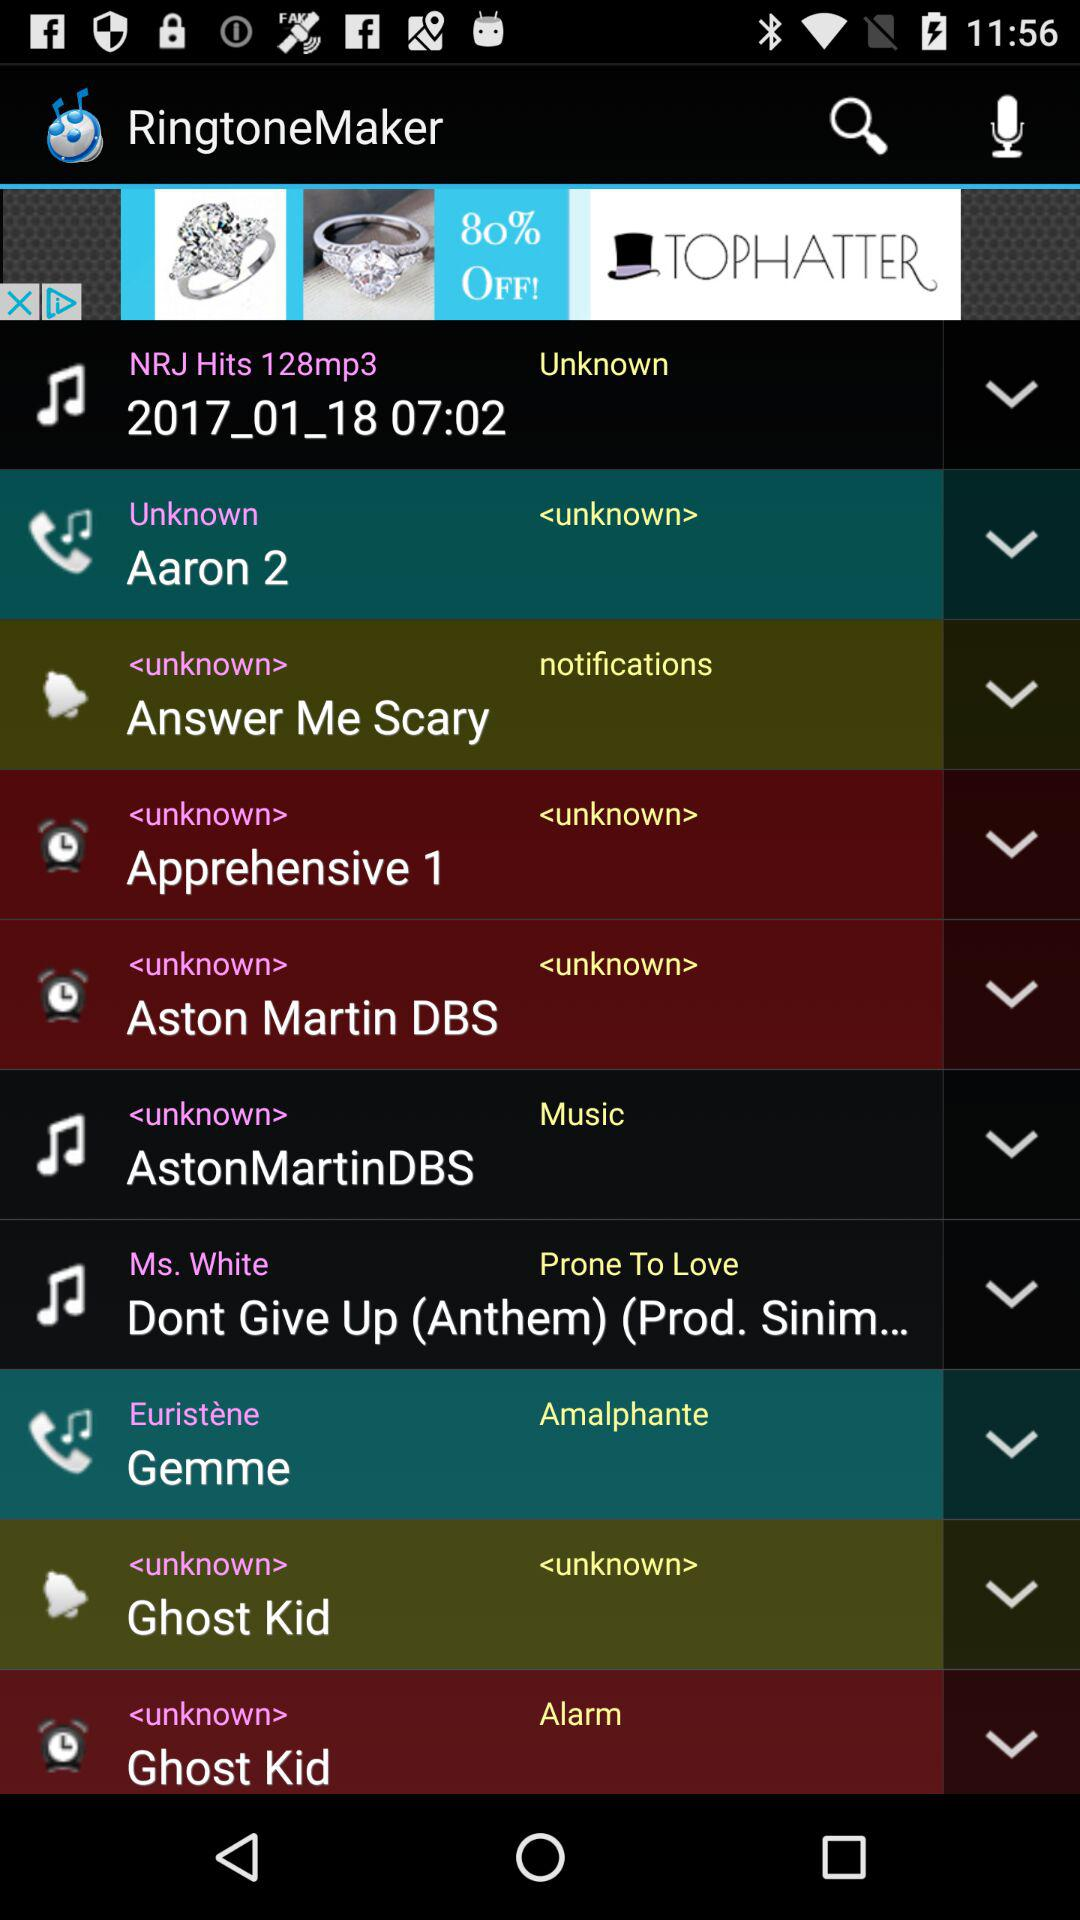Gemme is set for what group? The group is amalphante. 